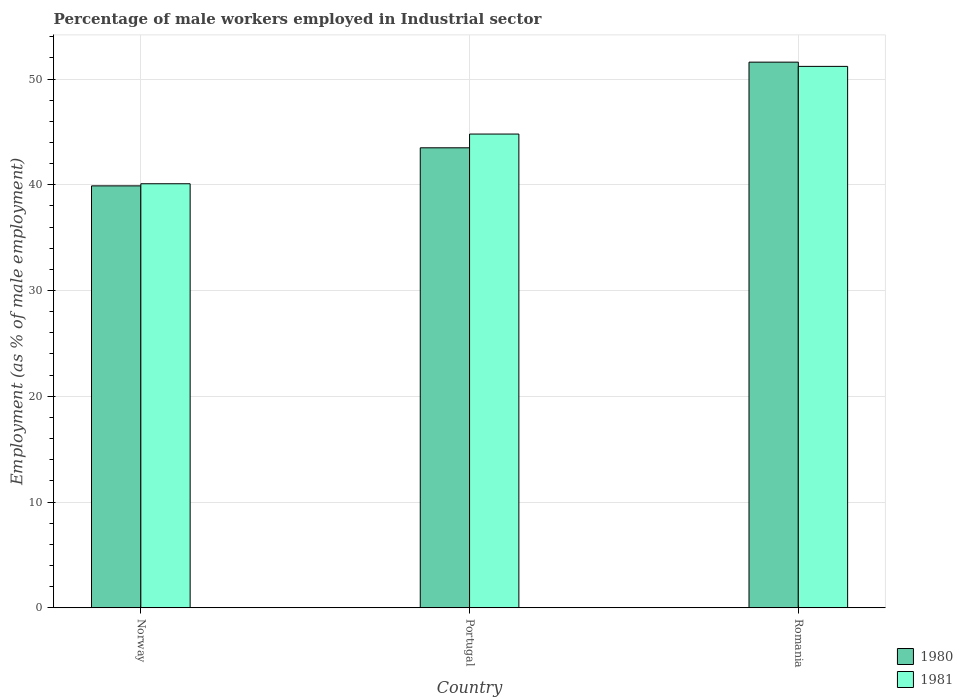Are the number of bars on each tick of the X-axis equal?
Your answer should be compact. Yes. How many bars are there on the 3rd tick from the left?
Offer a very short reply. 2. In how many cases, is the number of bars for a given country not equal to the number of legend labels?
Offer a very short reply. 0. What is the percentage of male workers employed in Industrial sector in 1980 in Portugal?
Offer a very short reply. 43.5. Across all countries, what is the maximum percentage of male workers employed in Industrial sector in 1981?
Provide a succinct answer. 51.2. Across all countries, what is the minimum percentage of male workers employed in Industrial sector in 1981?
Keep it short and to the point. 40.1. In which country was the percentage of male workers employed in Industrial sector in 1980 maximum?
Keep it short and to the point. Romania. What is the total percentage of male workers employed in Industrial sector in 1981 in the graph?
Offer a very short reply. 136.1. What is the difference between the percentage of male workers employed in Industrial sector in 1980 in Norway and that in Romania?
Provide a succinct answer. -11.7. What is the difference between the percentage of male workers employed in Industrial sector in 1981 in Portugal and the percentage of male workers employed in Industrial sector in 1980 in Norway?
Your response must be concise. 4.9. What is the average percentage of male workers employed in Industrial sector in 1981 per country?
Ensure brevity in your answer.  45.37. What is the difference between the percentage of male workers employed in Industrial sector of/in 1981 and percentage of male workers employed in Industrial sector of/in 1980 in Norway?
Give a very brief answer. 0.2. What is the ratio of the percentage of male workers employed in Industrial sector in 1980 in Norway to that in Portugal?
Give a very brief answer. 0.92. Is the difference between the percentage of male workers employed in Industrial sector in 1981 in Portugal and Romania greater than the difference between the percentage of male workers employed in Industrial sector in 1980 in Portugal and Romania?
Keep it short and to the point. Yes. What is the difference between the highest and the second highest percentage of male workers employed in Industrial sector in 1980?
Make the answer very short. -8.1. What is the difference between the highest and the lowest percentage of male workers employed in Industrial sector in 1980?
Your answer should be very brief. 11.7. In how many countries, is the percentage of male workers employed in Industrial sector in 1981 greater than the average percentage of male workers employed in Industrial sector in 1981 taken over all countries?
Offer a terse response. 1. What does the 2nd bar from the left in Norway represents?
Give a very brief answer. 1981. What does the 1st bar from the right in Portugal represents?
Make the answer very short. 1981. How many bars are there?
Provide a succinct answer. 6. How many countries are there in the graph?
Ensure brevity in your answer.  3. Are the values on the major ticks of Y-axis written in scientific E-notation?
Give a very brief answer. No. Does the graph contain any zero values?
Provide a short and direct response. No. How many legend labels are there?
Your answer should be very brief. 2. What is the title of the graph?
Your answer should be very brief. Percentage of male workers employed in Industrial sector. What is the label or title of the Y-axis?
Offer a terse response. Employment (as % of male employment). What is the Employment (as % of male employment) in 1980 in Norway?
Offer a terse response. 39.9. What is the Employment (as % of male employment) in 1981 in Norway?
Provide a succinct answer. 40.1. What is the Employment (as % of male employment) in 1980 in Portugal?
Keep it short and to the point. 43.5. What is the Employment (as % of male employment) of 1981 in Portugal?
Offer a very short reply. 44.8. What is the Employment (as % of male employment) of 1980 in Romania?
Your answer should be very brief. 51.6. What is the Employment (as % of male employment) of 1981 in Romania?
Keep it short and to the point. 51.2. Across all countries, what is the maximum Employment (as % of male employment) in 1980?
Offer a terse response. 51.6. Across all countries, what is the maximum Employment (as % of male employment) in 1981?
Provide a short and direct response. 51.2. Across all countries, what is the minimum Employment (as % of male employment) in 1980?
Ensure brevity in your answer.  39.9. Across all countries, what is the minimum Employment (as % of male employment) of 1981?
Offer a terse response. 40.1. What is the total Employment (as % of male employment) in 1980 in the graph?
Provide a short and direct response. 135. What is the total Employment (as % of male employment) of 1981 in the graph?
Your response must be concise. 136.1. What is the difference between the Employment (as % of male employment) in 1980 in Norway and that in Romania?
Ensure brevity in your answer.  -11.7. What is the difference between the Employment (as % of male employment) of 1980 in Norway and the Employment (as % of male employment) of 1981 in Portugal?
Provide a short and direct response. -4.9. What is the difference between the Employment (as % of male employment) of 1980 in Portugal and the Employment (as % of male employment) of 1981 in Romania?
Your answer should be compact. -7.7. What is the average Employment (as % of male employment) of 1980 per country?
Ensure brevity in your answer.  45. What is the average Employment (as % of male employment) of 1981 per country?
Your answer should be very brief. 45.37. What is the difference between the Employment (as % of male employment) of 1980 and Employment (as % of male employment) of 1981 in Norway?
Offer a very short reply. -0.2. What is the difference between the Employment (as % of male employment) in 1980 and Employment (as % of male employment) in 1981 in Portugal?
Make the answer very short. -1.3. What is the ratio of the Employment (as % of male employment) of 1980 in Norway to that in Portugal?
Offer a very short reply. 0.92. What is the ratio of the Employment (as % of male employment) of 1981 in Norway to that in Portugal?
Your response must be concise. 0.9. What is the ratio of the Employment (as % of male employment) of 1980 in Norway to that in Romania?
Your answer should be compact. 0.77. What is the ratio of the Employment (as % of male employment) of 1981 in Norway to that in Romania?
Offer a very short reply. 0.78. What is the ratio of the Employment (as % of male employment) of 1980 in Portugal to that in Romania?
Keep it short and to the point. 0.84. What is the difference between the highest and the lowest Employment (as % of male employment) of 1980?
Your answer should be very brief. 11.7. 